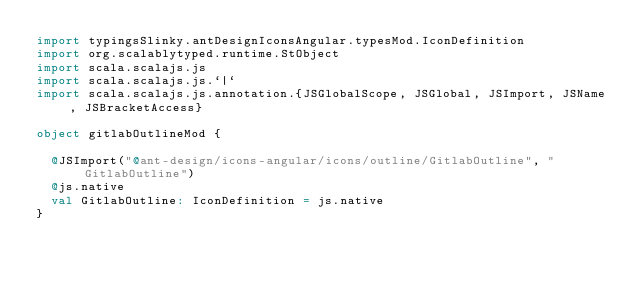Convert code to text. <code><loc_0><loc_0><loc_500><loc_500><_Scala_>import typingsSlinky.antDesignIconsAngular.typesMod.IconDefinition
import org.scalablytyped.runtime.StObject
import scala.scalajs.js
import scala.scalajs.js.`|`
import scala.scalajs.js.annotation.{JSGlobalScope, JSGlobal, JSImport, JSName, JSBracketAccess}

object gitlabOutlineMod {
  
  @JSImport("@ant-design/icons-angular/icons/outline/GitlabOutline", "GitlabOutline")
  @js.native
  val GitlabOutline: IconDefinition = js.native
}
</code> 